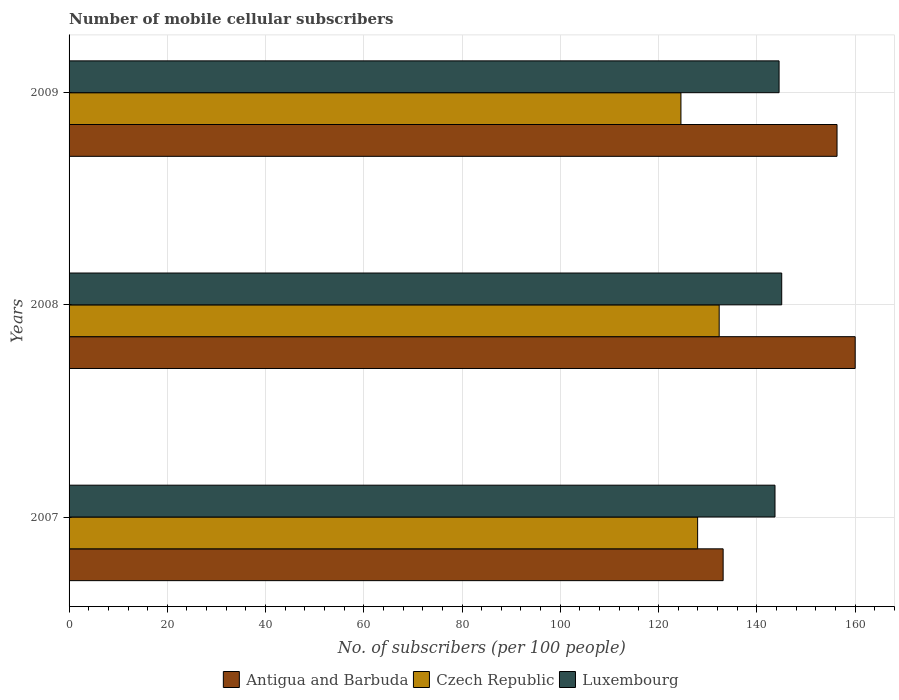Are the number of bars on each tick of the Y-axis equal?
Keep it short and to the point. Yes. How many bars are there on the 2nd tick from the top?
Give a very brief answer. 3. What is the label of the 3rd group of bars from the top?
Your response must be concise. 2007. What is the number of mobile cellular subscribers in Luxembourg in 2007?
Provide a short and direct response. 143.71. Across all years, what is the maximum number of mobile cellular subscribers in Czech Republic?
Provide a short and direct response. 132.35. Across all years, what is the minimum number of mobile cellular subscribers in Czech Republic?
Provide a short and direct response. 124.57. In which year was the number of mobile cellular subscribers in Luxembourg minimum?
Keep it short and to the point. 2007. What is the total number of mobile cellular subscribers in Antigua and Barbuda in the graph?
Provide a succinct answer. 449.54. What is the difference between the number of mobile cellular subscribers in Antigua and Barbuda in 2007 and that in 2009?
Your response must be concise. -23.19. What is the difference between the number of mobile cellular subscribers in Czech Republic in 2009 and the number of mobile cellular subscribers in Antigua and Barbuda in 2008?
Offer a very short reply. -35.47. What is the average number of mobile cellular subscribers in Czech Republic per year?
Offer a terse response. 128.29. In the year 2007, what is the difference between the number of mobile cellular subscribers in Antigua and Barbuda and number of mobile cellular subscribers in Luxembourg?
Your answer should be compact. -10.56. What is the ratio of the number of mobile cellular subscribers in Antigua and Barbuda in 2007 to that in 2009?
Ensure brevity in your answer.  0.85. What is the difference between the highest and the second highest number of mobile cellular subscribers in Luxembourg?
Ensure brevity in your answer.  0.54. What is the difference between the highest and the lowest number of mobile cellular subscribers in Antigua and Barbuda?
Provide a succinct answer. 26.88. In how many years, is the number of mobile cellular subscribers in Luxembourg greater than the average number of mobile cellular subscribers in Luxembourg taken over all years?
Your answer should be very brief. 2. Is the sum of the number of mobile cellular subscribers in Czech Republic in 2007 and 2008 greater than the maximum number of mobile cellular subscribers in Luxembourg across all years?
Provide a succinct answer. Yes. What does the 1st bar from the top in 2007 represents?
Your answer should be compact. Luxembourg. What does the 1st bar from the bottom in 2009 represents?
Your answer should be compact. Antigua and Barbuda. How many years are there in the graph?
Your response must be concise. 3. What is the difference between two consecutive major ticks on the X-axis?
Keep it short and to the point. 20. Does the graph contain any zero values?
Give a very brief answer. No. How many legend labels are there?
Provide a succinct answer. 3. How are the legend labels stacked?
Your answer should be compact. Horizontal. What is the title of the graph?
Provide a short and direct response. Number of mobile cellular subscribers. Does "Poland" appear as one of the legend labels in the graph?
Keep it short and to the point. No. What is the label or title of the X-axis?
Ensure brevity in your answer.  No. of subscribers (per 100 people). What is the label or title of the Y-axis?
Your answer should be compact. Years. What is the No. of subscribers (per 100 people) in Antigua and Barbuda in 2007?
Give a very brief answer. 133.16. What is the No. of subscribers (per 100 people) of Czech Republic in 2007?
Ensure brevity in your answer.  127.96. What is the No. of subscribers (per 100 people) in Luxembourg in 2007?
Give a very brief answer. 143.71. What is the No. of subscribers (per 100 people) in Antigua and Barbuda in 2008?
Your answer should be compact. 160.04. What is the No. of subscribers (per 100 people) in Czech Republic in 2008?
Give a very brief answer. 132.35. What is the No. of subscribers (per 100 people) of Luxembourg in 2008?
Keep it short and to the point. 145.08. What is the No. of subscribers (per 100 people) in Antigua and Barbuda in 2009?
Offer a very short reply. 156.34. What is the No. of subscribers (per 100 people) in Czech Republic in 2009?
Provide a succinct answer. 124.57. What is the No. of subscribers (per 100 people) of Luxembourg in 2009?
Your answer should be compact. 144.54. Across all years, what is the maximum No. of subscribers (per 100 people) of Antigua and Barbuda?
Your response must be concise. 160.04. Across all years, what is the maximum No. of subscribers (per 100 people) of Czech Republic?
Your answer should be very brief. 132.35. Across all years, what is the maximum No. of subscribers (per 100 people) of Luxembourg?
Make the answer very short. 145.08. Across all years, what is the minimum No. of subscribers (per 100 people) of Antigua and Barbuda?
Your response must be concise. 133.16. Across all years, what is the minimum No. of subscribers (per 100 people) of Czech Republic?
Offer a very short reply. 124.57. Across all years, what is the minimum No. of subscribers (per 100 people) of Luxembourg?
Offer a very short reply. 143.71. What is the total No. of subscribers (per 100 people) in Antigua and Barbuda in the graph?
Offer a terse response. 449.54. What is the total No. of subscribers (per 100 people) of Czech Republic in the graph?
Offer a terse response. 384.88. What is the total No. of subscribers (per 100 people) of Luxembourg in the graph?
Ensure brevity in your answer.  433.34. What is the difference between the No. of subscribers (per 100 people) in Antigua and Barbuda in 2007 and that in 2008?
Your answer should be very brief. -26.88. What is the difference between the No. of subscribers (per 100 people) in Czech Republic in 2007 and that in 2008?
Your answer should be compact. -4.39. What is the difference between the No. of subscribers (per 100 people) in Luxembourg in 2007 and that in 2008?
Ensure brevity in your answer.  -1.37. What is the difference between the No. of subscribers (per 100 people) of Antigua and Barbuda in 2007 and that in 2009?
Your answer should be compact. -23.19. What is the difference between the No. of subscribers (per 100 people) of Czech Republic in 2007 and that in 2009?
Ensure brevity in your answer.  3.4. What is the difference between the No. of subscribers (per 100 people) of Luxembourg in 2007 and that in 2009?
Your answer should be compact. -0.83. What is the difference between the No. of subscribers (per 100 people) of Antigua and Barbuda in 2008 and that in 2009?
Your answer should be compact. 3.7. What is the difference between the No. of subscribers (per 100 people) of Czech Republic in 2008 and that in 2009?
Your answer should be very brief. 7.78. What is the difference between the No. of subscribers (per 100 people) in Luxembourg in 2008 and that in 2009?
Give a very brief answer. 0.54. What is the difference between the No. of subscribers (per 100 people) of Antigua and Barbuda in 2007 and the No. of subscribers (per 100 people) of Czech Republic in 2008?
Make the answer very short. 0.81. What is the difference between the No. of subscribers (per 100 people) of Antigua and Barbuda in 2007 and the No. of subscribers (per 100 people) of Luxembourg in 2008?
Your response must be concise. -11.92. What is the difference between the No. of subscribers (per 100 people) in Czech Republic in 2007 and the No. of subscribers (per 100 people) in Luxembourg in 2008?
Offer a very short reply. -17.12. What is the difference between the No. of subscribers (per 100 people) of Antigua and Barbuda in 2007 and the No. of subscribers (per 100 people) of Czech Republic in 2009?
Your response must be concise. 8.59. What is the difference between the No. of subscribers (per 100 people) of Antigua and Barbuda in 2007 and the No. of subscribers (per 100 people) of Luxembourg in 2009?
Provide a short and direct response. -11.39. What is the difference between the No. of subscribers (per 100 people) of Czech Republic in 2007 and the No. of subscribers (per 100 people) of Luxembourg in 2009?
Give a very brief answer. -16.58. What is the difference between the No. of subscribers (per 100 people) in Antigua and Barbuda in 2008 and the No. of subscribers (per 100 people) in Czech Republic in 2009?
Your answer should be very brief. 35.47. What is the difference between the No. of subscribers (per 100 people) in Antigua and Barbuda in 2008 and the No. of subscribers (per 100 people) in Luxembourg in 2009?
Ensure brevity in your answer.  15.49. What is the difference between the No. of subscribers (per 100 people) of Czech Republic in 2008 and the No. of subscribers (per 100 people) of Luxembourg in 2009?
Make the answer very short. -12.19. What is the average No. of subscribers (per 100 people) of Antigua and Barbuda per year?
Offer a terse response. 149.85. What is the average No. of subscribers (per 100 people) in Czech Republic per year?
Make the answer very short. 128.29. What is the average No. of subscribers (per 100 people) of Luxembourg per year?
Provide a succinct answer. 144.45. In the year 2007, what is the difference between the No. of subscribers (per 100 people) in Antigua and Barbuda and No. of subscribers (per 100 people) in Czech Republic?
Provide a short and direct response. 5.19. In the year 2007, what is the difference between the No. of subscribers (per 100 people) in Antigua and Barbuda and No. of subscribers (per 100 people) in Luxembourg?
Provide a succinct answer. -10.56. In the year 2007, what is the difference between the No. of subscribers (per 100 people) of Czech Republic and No. of subscribers (per 100 people) of Luxembourg?
Your answer should be compact. -15.75. In the year 2008, what is the difference between the No. of subscribers (per 100 people) of Antigua and Barbuda and No. of subscribers (per 100 people) of Czech Republic?
Make the answer very short. 27.69. In the year 2008, what is the difference between the No. of subscribers (per 100 people) in Antigua and Barbuda and No. of subscribers (per 100 people) in Luxembourg?
Give a very brief answer. 14.96. In the year 2008, what is the difference between the No. of subscribers (per 100 people) of Czech Republic and No. of subscribers (per 100 people) of Luxembourg?
Your answer should be very brief. -12.73. In the year 2009, what is the difference between the No. of subscribers (per 100 people) of Antigua and Barbuda and No. of subscribers (per 100 people) of Czech Republic?
Your answer should be compact. 31.78. In the year 2009, what is the difference between the No. of subscribers (per 100 people) of Antigua and Barbuda and No. of subscribers (per 100 people) of Luxembourg?
Give a very brief answer. 11.8. In the year 2009, what is the difference between the No. of subscribers (per 100 people) in Czech Republic and No. of subscribers (per 100 people) in Luxembourg?
Keep it short and to the point. -19.98. What is the ratio of the No. of subscribers (per 100 people) in Antigua and Barbuda in 2007 to that in 2008?
Provide a short and direct response. 0.83. What is the ratio of the No. of subscribers (per 100 people) of Czech Republic in 2007 to that in 2008?
Your response must be concise. 0.97. What is the ratio of the No. of subscribers (per 100 people) of Luxembourg in 2007 to that in 2008?
Your answer should be compact. 0.99. What is the ratio of the No. of subscribers (per 100 people) in Antigua and Barbuda in 2007 to that in 2009?
Keep it short and to the point. 0.85. What is the ratio of the No. of subscribers (per 100 people) of Czech Republic in 2007 to that in 2009?
Ensure brevity in your answer.  1.03. What is the ratio of the No. of subscribers (per 100 people) in Antigua and Barbuda in 2008 to that in 2009?
Provide a short and direct response. 1.02. What is the ratio of the No. of subscribers (per 100 people) in Czech Republic in 2008 to that in 2009?
Offer a very short reply. 1.06. What is the ratio of the No. of subscribers (per 100 people) in Luxembourg in 2008 to that in 2009?
Your answer should be very brief. 1. What is the difference between the highest and the second highest No. of subscribers (per 100 people) in Antigua and Barbuda?
Keep it short and to the point. 3.7. What is the difference between the highest and the second highest No. of subscribers (per 100 people) of Czech Republic?
Your response must be concise. 4.39. What is the difference between the highest and the second highest No. of subscribers (per 100 people) of Luxembourg?
Provide a succinct answer. 0.54. What is the difference between the highest and the lowest No. of subscribers (per 100 people) in Antigua and Barbuda?
Give a very brief answer. 26.88. What is the difference between the highest and the lowest No. of subscribers (per 100 people) in Czech Republic?
Offer a very short reply. 7.78. What is the difference between the highest and the lowest No. of subscribers (per 100 people) in Luxembourg?
Your answer should be compact. 1.37. 